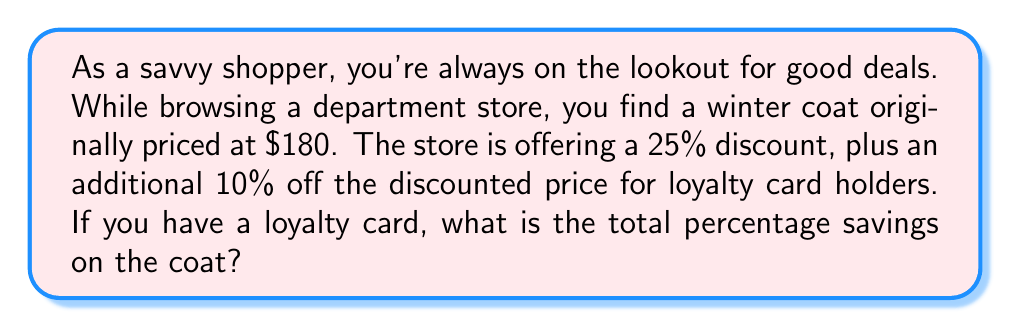Teach me how to tackle this problem. Let's approach this step-by-step:

1) First, let's calculate the price after the initial 25% discount:
   $180 - (25\% \text{ of } 180) = 180 - (0.25 \times 180) = 180 - 45 = $135

2) Now, we apply the additional 10% discount to this new price:
   $135 - (10\% \text{ of } 135) = 135 - (0.10 \times 135) = 135 - 13.50 = $121.50

3) To find the total savings, we subtract the final price from the original price:
   $180 - $121.50 = $58.50

4) To calculate the percentage savings, we use the formula:
   $\text{Percentage Savings} = \frac{\text{Amount Saved}}{\text{Original Price}} \times 100\%$

   $$\text{Percentage Savings} = \frac{58.50}{180} \times 100\% = 0.325 \times 100\% = 32.5\%$$

5) We can also verify this by calculating the combined discount:
   First discount: 25%
   Second discount: 10% of the remaining 75% = 0.10 × 0.75 = 7.5%
   Total discount: 25% + 7.5% = 32.5%

This matches our calculated percentage savings.
Answer: The total percentage savings on the coat is 32.5%. 